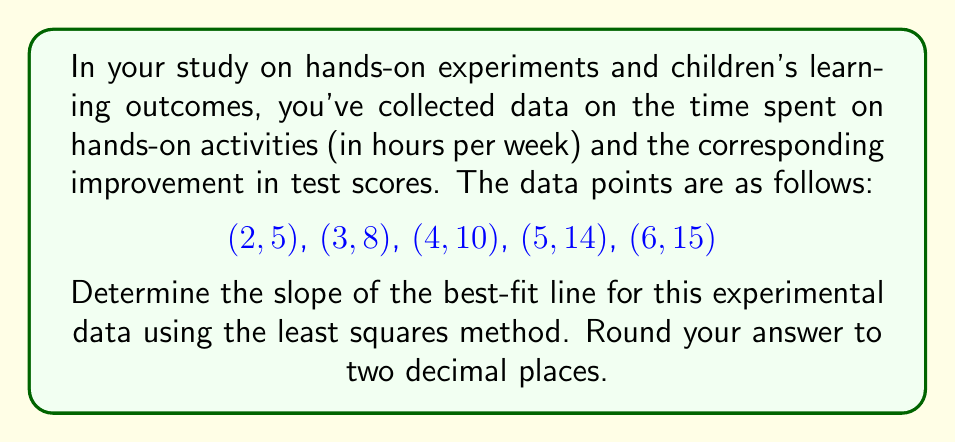Show me your answer to this math problem. To find the slope of the best-fit line using the least squares method, we'll use the formula:

$$ m = \frac{n\sum xy - \sum x \sum y}{n\sum x^2 - (\sum x)^2} $$

Where:
$m$ is the slope
$n$ is the number of data points
$x$ represents time spent on hands-on activities
$y$ represents improvement in test scores

Let's calculate the necessary sums:

1) $n = 5$ (number of data points)

2) $\sum x = 2 + 3 + 4 + 5 + 6 = 20$

3) $\sum y = 5 + 8 + 10 + 14 + 15 = 52$

4) $\sum xy = (2 \cdot 5) + (3 \cdot 8) + (4 \cdot 10) + (5 \cdot 14) + (6 \cdot 15) = 10 + 24 + 40 + 70 + 90 = 234$

5) $\sum x^2 = 2^2 + 3^2 + 4^2 + 5^2 + 6^2 = 4 + 9 + 16 + 25 + 36 = 90$

Now, let's substitute these values into the slope formula:

$$ m = \frac{5(234) - (20)(52)}{5(90) - (20)^2} $$

$$ m = \frac{1170 - 1040}{450 - 400} $$

$$ m = \frac{130}{50} = 2.6 $$

Therefore, the slope of the best-fit line is 2.6.
Answer: 2.60 